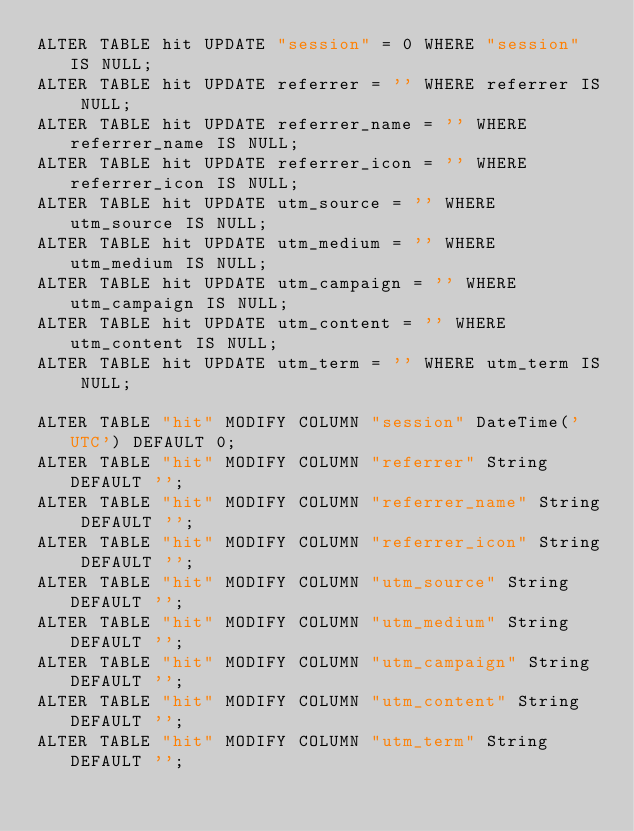<code> <loc_0><loc_0><loc_500><loc_500><_SQL_>ALTER TABLE hit UPDATE "session" = 0 WHERE "session" IS NULL;
ALTER TABLE hit UPDATE referrer = '' WHERE referrer IS NULL;
ALTER TABLE hit UPDATE referrer_name = '' WHERE referrer_name IS NULL;
ALTER TABLE hit UPDATE referrer_icon = '' WHERE referrer_icon IS NULL;
ALTER TABLE hit UPDATE utm_source = '' WHERE utm_source IS NULL;
ALTER TABLE hit UPDATE utm_medium = '' WHERE utm_medium IS NULL;
ALTER TABLE hit UPDATE utm_campaign = '' WHERE utm_campaign IS NULL;
ALTER TABLE hit UPDATE utm_content = '' WHERE utm_content IS NULL;
ALTER TABLE hit UPDATE utm_term = '' WHERE utm_term IS NULL;

ALTER TABLE "hit" MODIFY COLUMN "session" DateTime('UTC') DEFAULT 0;
ALTER TABLE "hit" MODIFY COLUMN "referrer" String DEFAULT '';
ALTER TABLE "hit" MODIFY COLUMN "referrer_name" String DEFAULT '';
ALTER TABLE "hit" MODIFY COLUMN "referrer_icon" String DEFAULT '';
ALTER TABLE "hit" MODIFY COLUMN "utm_source" String DEFAULT '';
ALTER TABLE "hit" MODIFY COLUMN "utm_medium" String DEFAULT '';
ALTER TABLE "hit" MODIFY COLUMN "utm_campaign" String DEFAULT '';
ALTER TABLE "hit" MODIFY COLUMN "utm_content" String DEFAULT '';
ALTER TABLE "hit" MODIFY COLUMN "utm_term" String DEFAULT '';
</code> 